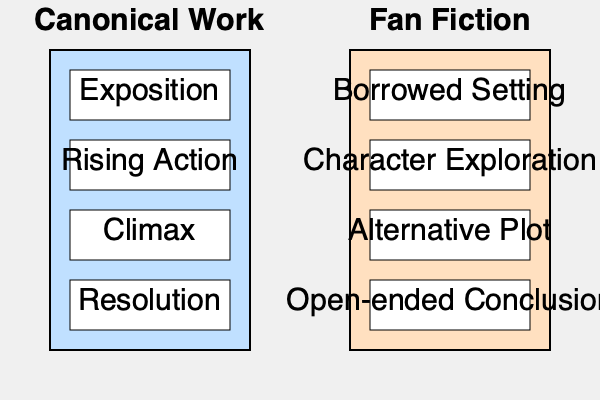Based on the flowchart comparing the narrative structure of canonical works and fan fiction, which element in fan fiction most clearly demonstrates its departure from the traditional storytelling arc found in canonical literature? To answer this question, we need to analyze the differences between the narrative structures presented in the flowchart:

1. Canonical Work structure:
   a. Exposition
   b. Rising Action
   c. Climax
   d. Resolution

2. Fan Fiction structure:
   a. Borrowed Setting
   b. Character Exploration
   c. Alternative Plot
   d. Open-ended Conclusion

3. Comparing the elements:
   a. The first element in fan fiction (Borrowed Setting) already indicates a departure from original storytelling, as it relies on an existing fictional universe.
   b. Character Exploration in fan fiction differs from Rising Action in canonical works, suggesting a focus on character development rather than plot progression.
   c. Alternative Plot in fan fiction replaces the Climax in canonical works, indicating a deviation from the original story's central conflict.
   d. The final element, Open-ended Conclusion, contrasts sharply with the Resolution in canonical works.

4. Analyzing the departures:
   a. Borrowed Setting and Character Exploration, while different, still have some parallels to Exposition and Rising Action in terms of story setup and development.
   b. Alternative Plot, while different, still maintains the concept of a central story event.
   c. Open-ended Conclusion represents the most significant departure from traditional storytelling, as it eschews the concept of a definitive ending or resolution typically found in canonical literature.

Therefore, the element that most clearly demonstrates fan fiction's departure from the traditional storytelling arc is the Open-ended Conclusion.
Answer: Open-ended Conclusion 